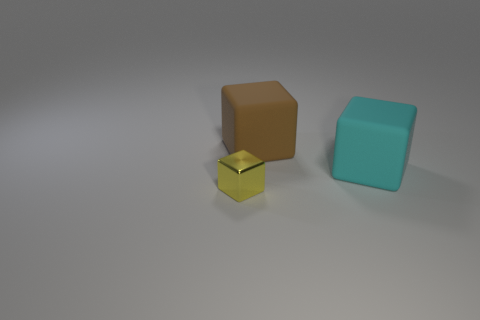How would you describe the lighting and mood of this image? The lighting in the image is soft and diffused, which casts gentle shadows and gives the scene a calm and serene mood. The choice of neutral background and muted colors of the objects further complement the tranquil ambiance of the composition. 